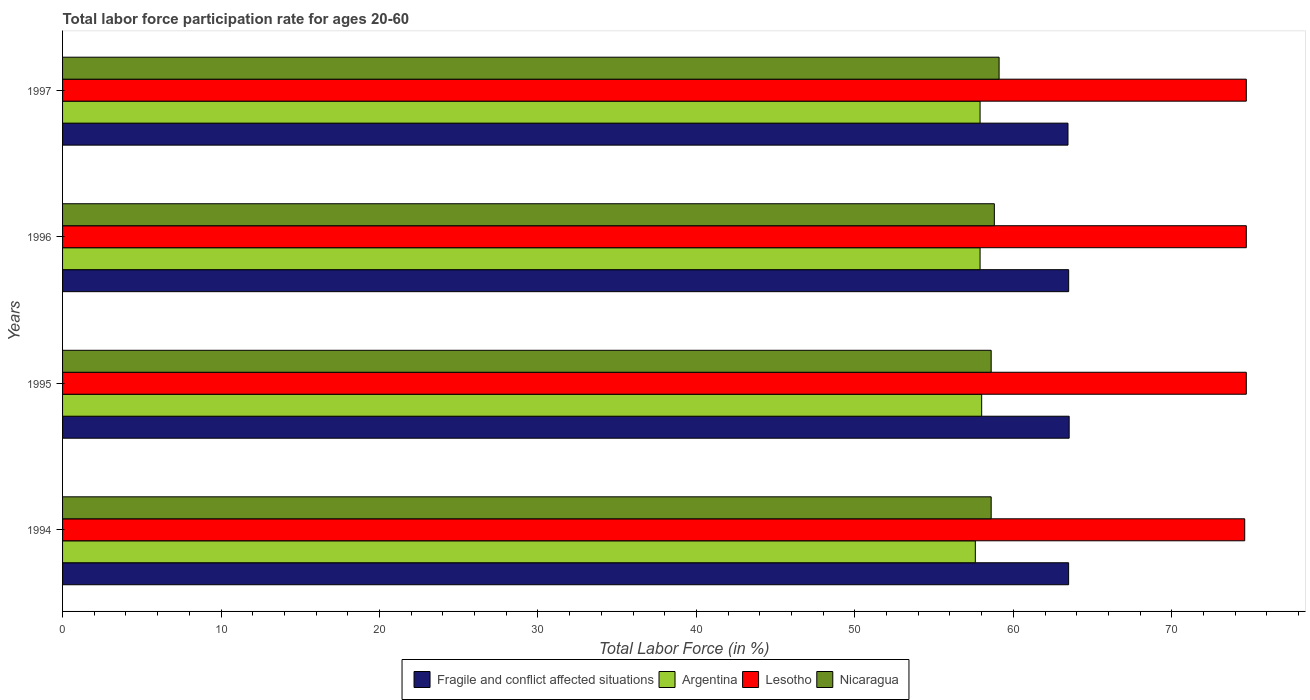Are the number of bars per tick equal to the number of legend labels?
Provide a succinct answer. Yes. How many bars are there on the 2nd tick from the top?
Give a very brief answer. 4. How many bars are there on the 1st tick from the bottom?
Keep it short and to the point. 4. What is the label of the 3rd group of bars from the top?
Provide a succinct answer. 1995. What is the labor force participation rate in Nicaragua in 1997?
Provide a succinct answer. 59.1. Across all years, what is the maximum labor force participation rate in Lesotho?
Your answer should be compact. 74.7. Across all years, what is the minimum labor force participation rate in Argentina?
Your answer should be compact. 57.6. In which year was the labor force participation rate in Lesotho maximum?
Provide a succinct answer. 1995. In which year was the labor force participation rate in Lesotho minimum?
Offer a terse response. 1994. What is the total labor force participation rate in Argentina in the graph?
Make the answer very short. 231.4. What is the difference between the labor force participation rate in Lesotho in 1996 and that in 1997?
Offer a very short reply. 0. What is the difference between the labor force participation rate in Fragile and conflict affected situations in 1996 and the labor force participation rate in Lesotho in 1997?
Your response must be concise. -11.21. What is the average labor force participation rate in Argentina per year?
Keep it short and to the point. 57.85. In the year 1997, what is the difference between the labor force participation rate in Lesotho and labor force participation rate in Argentina?
Offer a terse response. 16.8. What is the ratio of the labor force participation rate in Nicaragua in 1996 to that in 1997?
Make the answer very short. 0.99. Is the labor force participation rate in Lesotho in 1995 less than that in 1997?
Your answer should be compact. No. What is the difference between the highest and the lowest labor force participation rate in Lesotho?
Offer a terse response. 0.1. Is it the case that in every year, the sum of the labor force participation rate in Fragile and conflict affected situations and labor force participation rate in Lesotho is greater than the sum of labor force participation rate in Nicaragua and labor force participation rate in Argentina?
Make the answer very short. Yes. What does the 2nd bar from the top in 1995 represents?
Ensure brevity in your answer.  Lesotho. What does the 3rd bar from the bottom in 1996 represents?
Offer a terse response. Lesotho. How many years are there in the graph?
Offer a terse response. 4. Are the values on the major ticks of X-axis written in scientific E-notation?
Provide a succinct answer. No. Does the graph contain any zero values?
Your answer should be compact. No. Does the graph contain grids?
Give a very brief answer. No. Where does the legend appear in the graph?
Give a very brief answer. Bottom center. How many legend labels are there?
Your response must be concise. 4. How are the legend labels stacked?
Provide a succinct answer. Horizontal. What is the title of the graph?
Offer a very short reply. Total labor force participation rate for ages 20-60. What is the Total Labor Force (in %) in Fragile and conflict affected situations in 1994?
Make the answer very short. 63.49. What is the Total Labor Force (in %) in Argentina in 1994?
Your answer should be compact. 57.6. What is the Total Labor Force (in %) of Lesotho in 1994?
Offer a terse response. 74.6. What is the Total Labor Force (in %) of Nicaragua in 1994?
Offer a terse response. 58.6. What is the Total Labor Force (in %) in Fragile and conflict affected situations in 1995?
Keep it short and to the point. 63.52. What is the Total Labor Force (in %) of Argentina in 1995?
Make the answer very short. 58. What is the Total Labor Force (in %) in Lesotho in 1995?
Make the answer very short. 74.7. What is the Total Labor Force (in %) in Nicaragua in 1995?
Your answer should be very brief. 58.6. What is the Total Labor Force (in %) of Fragile and conflict affected situations in 1996?
Provide a succinct answer. 63.49. What is the Total Labor Force (in %) in Argentina in 1996?
Your answer should be compact. 57.9. What is the Total Labor Force (in %) of Lesotho in 1996?
Make the answer very short. 74.7. What is the Total Labor Force (in %) of Nicaragua in 1996?
Keep it short and to the point. 58.8. What is the Total Labor Force (in %) of Fragile and conflict affected situations in 1997?
Keep it short and to the point. 63.45. What is the Total Labor Force (in %) of Argentina in 1997?
Your answer should be very brief. 57.9. What is the Total Labor Force (in %) of Lesotho in 1997?
Provide a succinct answer. 74.7. What is the Total Labor Force (in %) of Nicaragua in 1997?
Provide a short and direct response. 59.1. Across all years, what is the maximum Total Labor Force (in %) in Fragile and conflict affected situations?
Offer a terse response. 63.52. Across all years, what is the maximum Total Labor Force (in %) in Argentina?
Provide a succinct answer. 58. Across all years, what is the maximum Total Labor Force (in %) of Lesotho?
Your answer should be compact. 74.7. Across all years, what is the maximum Total Labor Force (in %) of Nicaragua?
Give a very brief answer. 59.1. Across all years, what is the minimum Total Labor Force (in %) in Fragile and conflict affected situations?
Provide a succinct answer. 63.45. Across all years, what is the minimum Total Labor Force (in %) of Argentina?
Give a very brief answer. 57.6. Across all years, what is the minimum Total Labor Force (in %) in Lesotho?
Offer a terse response. 74.6. Across all years, what is the minimum Total Labor Force (in %) of Nicaragua?
Provide a short and direct response. 58.6. What is the total Total Labor Force (in %) of Fragile and conflict affected situations in the graph?
Provide a succinct answer. 253.95. What is the total Total Labor Force (in %) of Argentina in the graph?
Ensure brevity in your answer.  231.4. What is the total Total Labor Force (in %) of Lesotho in the graph?
Your answer should be very brief. 298.7. What is the total Total Labor Force (in %) in Nicaragua in the graph?
Your answer should be compact. 235.1. What is the difference between the Total Labor Force (in %) in Fragile and conflict affected situations in 1994 and that in 1995?
Your answer should be compact. -0.03. What is the difference between the Total Labor Force (in %) of Lesotho in 1994 and that in 1995?
Offer a very short reply. -0.1. What is the difference between the Total Labor Force (in %) of Nicaragua in 1994 and that in 1995?
Your answer should be very brief. 0. What is the difference between the Total Labor Force (in %) of Fragile and conflict affected situations in 1994 and that in 1996?
Offer a terse response. -0. What is the difference between the Total Labor Force (in %) in Lesotho in 1994 and that in 1996?
Your answer should be compact. -0.1. What is the difference between the Total Labor Force (in %) of Fragile and conflict affected situations in 1994 and that in 1997?
Provide a short and direct response. 0.04. What is the difference between the Total Labor Force (in %) in Argentina in 1994 and that in 1997?
Offer a terse response. -0.3. What is the difference between the Total Labor Force (in %) in Lesotho in 1994 and that in 1997?
Offer a terse response. -0.1. What is the difference between the Total Labor Force (in %) in Fragile and conflict affected situations in 1995 and that in 1996?
Your answer should be very brief. 0.03. What is the difference between the Total Labor Force (in %) in Argentina in 1995 and that in 1996?
Ensure brevity in your answer.  0.1. What is the difference between the Total Labor Force (in %) in Lesotho in 1995 and that in 1996?
Make the answer very short. 0. What is the difference between the Total Labor Force (in %) of Nicaragua in 1995 and that in 1996?
Make the answer very short. -0.2. What is the difference between the Total Labor Force (in %) in Fragile and conflict affected situations in 1995 and that in 1997?
Provide a succinct answer. 0.07. What is the difference between the Total Labor Force (in %) of Fragile and conflict affected situations in 1996 and that in 1997?
Your answer should be compact. 0.04. What is the difference between the Total Labor Force (in %) in Nicaragua in 1996 and that in 1997?
Your answer should be very brief. -0.3. What is the difference between the Total Labor Force (in %) of Fragile and conflict affected situations in 1994 and the Total Labor Force (in %) of Argentina in 1995?
Make the answer very short. 5.49. What is the difference between the Total Labor Force (in %) in Fragile and conflict affected situations in 1994 and the Total Labor Force (in %) in Lesotho in 1995?
Your answer should be very brief. -11.21. What is the difference between the Total Labor Force (in %) of Fragile and conflict affected situations in 1994 and the Total Labor Force (in %) of Nicaragua in 1995?
Your answer should be very brief. 4.89. What is the difference between the Total Labor Force (in %) in Argentina in 1994 and the Total Labor Force (in %) in Lesotho in 1995?
Ensure brevity in your answer.  -17.1. What is the difference between the Total Labor Force (in %) of Fragile and conflict affected situations in 1994 and the Total Labor Force (in %) of Argentina in 1996?
Keep it short and to the point. 5.59. What is the difference between the Total Labor Force (in %) of Fragile and conflict affected situations in 1994 and the Total Labor Force (in %) of Lesotho in 1996?
Ensure brevity in your answer.  -11.21. What is the difference between the Total Labor Force (in %) of Fragile and conflict affected situations in 1994 and the Total Labor Force (in %) of Nicaragua in 1996?
Provide a succinct answer. 4.69. What is the difference between the Total Labor Force (in %) of Argentina in 1994 and the Total Labor Force (in %) of Lesotho in 1996?
Make the answer very short. -17.1. What is the difference between the Total Labor Force (in %) in Argentina in 1994 and the Total Labor Force (in %) in Nicaragua in 1996?
Keep it short and to the point. -1.2. What is the difference between the Total Labor Force (in %) in Fragile and conflict affected situations in 1994 and the Total Labor Force (in %) in Argentina in 1997?
Ensure brevity in your answer.  5.59. What is the difference between the Total Labor Force (in %) in Fragile and conflict affected situations in 1994 and the Total Labor Force (in %) in Lesotho in 1997?
Keep it short and to the point. -11.21. What is the difference between the Total Labor Force (in %) in Fragile and conflict affected situations in 1994 and the Total Labor Force (in %) in Nicaragua in 1997?
Keep it short and to the point. 4.39. What is the difference between the Total Labor Force (in %) in Argentina in 1994 and the Total Labor Force (in %) in Lesotho in 1997?
Keep it short and to the point. -17.1. What is the difference between the Total Labor Force (in %) of Argentina in 1994 and the Total Labor Force (in %) of Nicaragua in 1997?
Ensure brevity in your answer.  -1.5. What is the difference between the Total Labor Force (in %) in Lesotho in 1994 and the Total Labor Force (in %) in Nicaragua in 1997?
Your answer should be compact. 15.5. What is the difference between the Total Labor Force (in %) of Fragile and conflict affected situations in 1995 and the Total Labor Force (in %) of Argentina in 1996?
Offer a terse response. 5.62. What is the difference between the Total Labor Force (in %) in Fragile and conflict affected situations in 1995 and the Total Labor Force (in %) in Lesotho in 1996?
Your answer should be compact. -11.18. What is the difference between the Total Labor Force (in %) in Fragile and conflict affected situations in 1995 and the Total Labor Force (in %) in Nicaragua in 1996?
Ensure brevity in your answer.  4.72. What is the difference between the Total Labor Force (in %) in Argentina in 1995 and the Total Labor Force (in %) in Lesotho in 1996?
Your answer should be very brief. -16.7. What is the difference between the Total Labor Force (in %) in Argentina in 1995 and the Total Labor Force (in %) in Nicaragua in 1996?
Your answer should be compact. -0.8. What is the difference between the Total Labor Force (in %) of Lesotho in 1995 and the Total Labor Force (in %) of Nicaragua in 1996?
Give a very brief answer. 15.9. What is the difference between the Total Labor Force (in %) of Fragile and conflict affected situations in 1995 and the Total Labor Force (in %) of Argentina in 1997?
Provide a succinct answer. 5.62. What is the difference between the Total Labor Force (in %) in Fragile and conflict affected situations in 1995 and the Total Labor Force (in %) in Lesotho in 1997?
Ensure brevity in your answer.  -11.18. What is the difference between the Total Labor Force (in %) of Fragile and conflict affected situations in 1995 and the Total Labor Force (in %) of Nicaragua in 1997?
Keep it short and to the point. 4.42. What is the difference between the Total Labor Force (in %) of Argentina in 1995 and the Total Labor Force (in %) of Lesotho in 1997?
Your answer should be compact. -16.7. What is the difference between the Total Labor Force (in %) of Argentina in 1995 and the Total Labor Force (in %) of Nicaragua in 1997?
Your answer should be very brief. -1.1. What is the difference between the Total Labor Force (in %) of Lesotho in 1995 and the Total Labor Force (in %) of Nicaragua in 1997?
Give a very brief answer. 15.6. What is the difference between the Total Labor Force (in %) of Fragile and conflict affected situations in 1996 and the Total Labor Force (in %) of Argentina in 1997?
Your response must be concise. 5.59. What is the difference between the Total Labor Force (in %) in Fragile and conflict affected situations in 1996 and the Total Labor Force (in %) in Lesotho in 1997?
Ensure brevity in your answer.  -11.21. What is the difference between the Total Labor Force (in %) in Fragile and conflict affected situations in 1996 and the Total Labor Force (in %) in Nicaragua in 1997?
Your answer should be very brief. 4.39. What is the difference between the Total Labor Force (in %) in Argentina in 1996 and the Total Labor Force (in %) in Lesotho in 1997?
Ensure brevity in your answer.  -16.8. What is the average Total Labor Force (in %) of Fragile and conflict affected situations per year?
Your response must be concise. 63.49. What is the average Total Labor Force (in %) of Argentina per year?
Make the answer very short. 57.85. What is the average Total Labor Force (in %) in Lesotho per year?
Provide a short and direct response. 74.67. What is the average Total Labor Force (in %) in Nicaragua per year?
Your answer should be very brief. 58.77. In the year 1994, what is the difference between the Total Labor Force (in %) of Fragile and conflict affected situations and Total Labor Force (in %) of Argentina?
Provide a short and direct response. 5.89. In the year 1994, what is the difference between the Total Labor Force (in %) in Fragile and conflict affected situations and Total Labor Force (in %) in Lesotho?
Give a very brief answer. -11.11. In the year 1994, what is the difference between the Total Labor Force (in %) in Fragile and conflict affected situations and Total Labor Force (in %) in Nicaragua?
Offer a terse response. 4.89. In the year 1994, what is the difference between the Total Labor Force (in %) of Argentina and Total Labor Force (in %) of Nicaragua?
Offer a very short reply. -1. In the year 1994, what is the difference between the Total Labor Force (in %) of Lesotho and Total Labor Force (in %) of Nicaragua?
Provide a succinct answer. 16. In the year 1995, what is the difference between the Total Labor Force (in %) in Fragile and conflict affected situations and Total Labor Force (in %) in Argentina?
Your response must be concise. 5.52. In the year 1995, what is the difference between the Total Labor Force (in %) of Fragile and conflict affected situations and Total Labor Force (in %) of Lesotho?
Provide a succinct answer. -11.18. In the year 1995, what is the difference between the Total Labor Force (in %) of Fragile and conflict affected situations and Total Labor Force (in %) of Nicaragua?
Keep it short and to the point. 4.92. In the year 1995, what is the difference between the Total Labor Force (in %) of Argentina and Total Labor Force (in %) of Lesotho?
Your answer should be compact. -16.7. In the year 1996, what is the difference between the Total Labor Force (in %) of Fragile and conflict affected situations and Total Labor Force (in %) of Argentina?
Provide a succinct answer. 5.59. In the year 1996, what is the difference between the Total Labor Force (in %) of Fragile and conflict affected situations and Total Labor Force (in %) of Lesotho?
Provide a succinct answer. -11.21. In the year 1996, what is the difference between the Total Labor Force (in %) of Fragile and conflict affected situations and Total Labor Force (in %) of Nicaragua?
Make the answer very short. 4.69. In the year 1996, what is the difference between the Total Labor Force (in %) in Argentina and Total Labor Force (in %) in Lesotho?
Offer a very short reply. -16.8. In the year 1996, what is the difference between the Total Labor Force (in %) in Lesotho and Total Labor Force (in %) in Nicaragua?
Offer a very short reply. 15.9. In the year 1997, what is the difference between the Total Labor Force (in %) in Fragile and conflict affected situations and Total Labor Force (in %) in Argentina?
Provide a short and direct response. 5.55. In the year 1997, what is the difference between the Total Labor Force (in %) in Fragile and conflict affected situations and Total Labor Force (in %) in Lesotho?
Provide a short and direct response. -11.25. In the year 1997, what is the difference between the Total Labor Force (in %) in Fragile and conflict affected situations and Total Labor Force (in %) in Nicaragua?
Your answer should be compact. 4.35. In the year 1997, what is the difference between the Total Labor Force (in %) of Argentina and Total Labor Force (in %) of Lesotho?
Offer a very short reply. -16.8. In the year 1997, what is the difference between the Total Labor Force (in %) of Argentina and Total Labor Force (in %) of Nicaragua?
Your response must be concise. -1.2. What is the ratio of the Total Labor Force (in %) in Nicaragua in 1994 to that in 1995?
Offer a very short reply. 1. What is the ratio of the Total Labor Force (in %) in Argentina in 1994 to that in 1996?
Your response must be concise. 0.99. What is the ratio of the Total Labor Force (in %) in Lesotho in 1994 to that in 1996?
Ensure brevity in your answer.  1. What is the ratio of the Total Labor Force (in %) of Nicaragua in 1994 to that in 1996?
Ensure brevity in your answer.  1. What is the ratio of the Total Labor Force (in %) of Argentina in 1994 to that in 1997?
Keep it short and to the point. 0.99. What is the ratio of the Total Labor Force (in %) of Lesotho in 1995 to that in 1996?
Ensure brevity in your answer.  1. What is the ratio of the Total Labor Force (in %) in Fragile and conflict affected situations in 1995 to that in 1997?
Make the answer very short. 1. What is the ratio of the Total Labor Force (in %) in Nicaragua in 1995 to that in 1997?
Provide a succinct answer. 0.99. What is the ratio of the Total Labor Force (in %) of Fragile and conflict affected situations in 1996 to that in 1997?
Ensure brevity in your answer.  1. What is the ratio of the Total Labor Force (in %) in Argentina in 1996 to that in 1997?
Offer a terse response. 1. What is the ratio of the Total Labor Force (in %) in Lesotho in 1996 to that in 1997?
Your response must be concise. 1. What is the difference between the highest and the second highest Total Labor Force (in %) in Fragile and conflict affected situations?
Your answer should be compact. 0.03. What is the difference between the highest and the lowest Total Labor Force (in %) of Fragile and conflict affected situations?
Make the answer very short. 0.07. What is the difference between the highest and the lowest Total Labor Force (in %) in Lesotho?
Your answer should be very brief. 0.1. What is the difference between the highest and the lowest Total Labor Force (in %) in Nicaragua?
Your answer should be compact. 0.5. 